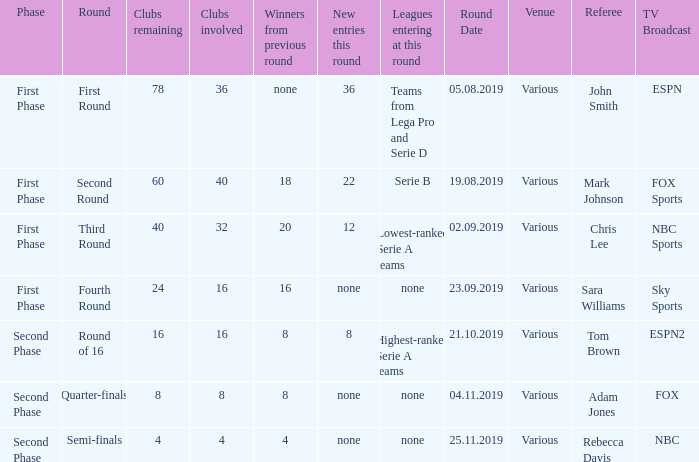Clubs involved is 8, what number would you find from winners from previous round? 8.0. 